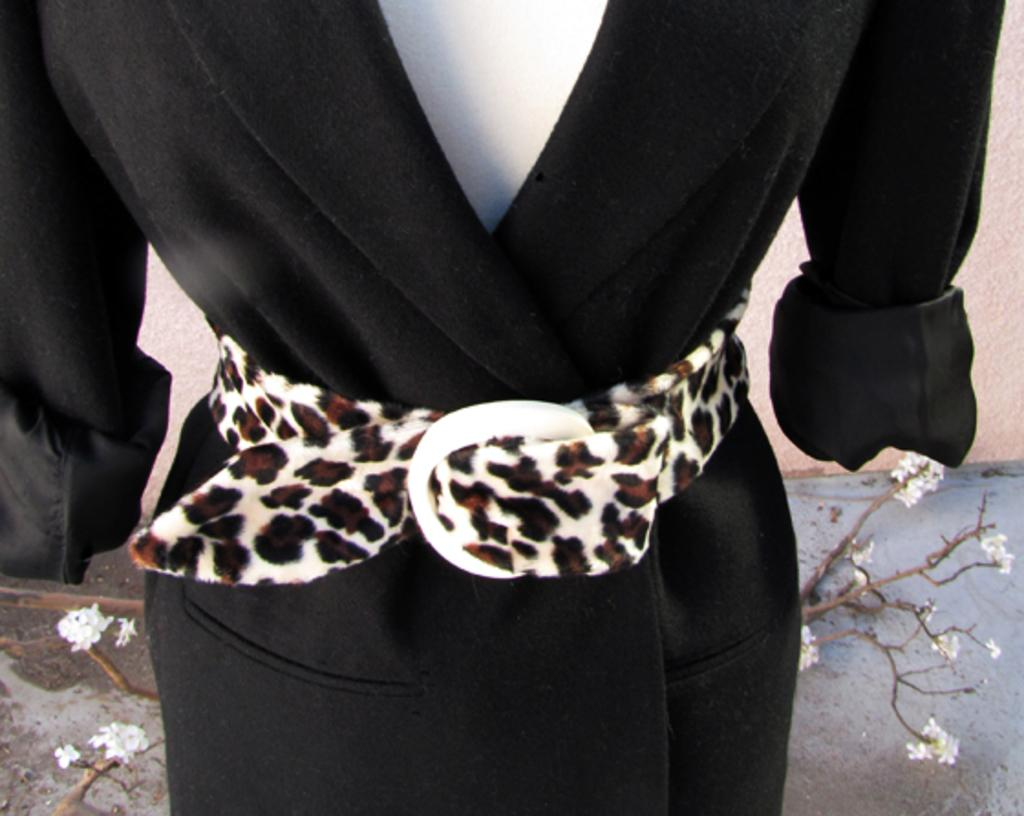What is the main subject of the image? There is a mannequin in the image. What is the mannequin wearing? The mannequin is wearing a dress. What can be seen in the background of the image? There are branches with flowers in the background of the image. What is the mannequin's income in the image? The mannequin is not a real person and therefore does not have an income. 